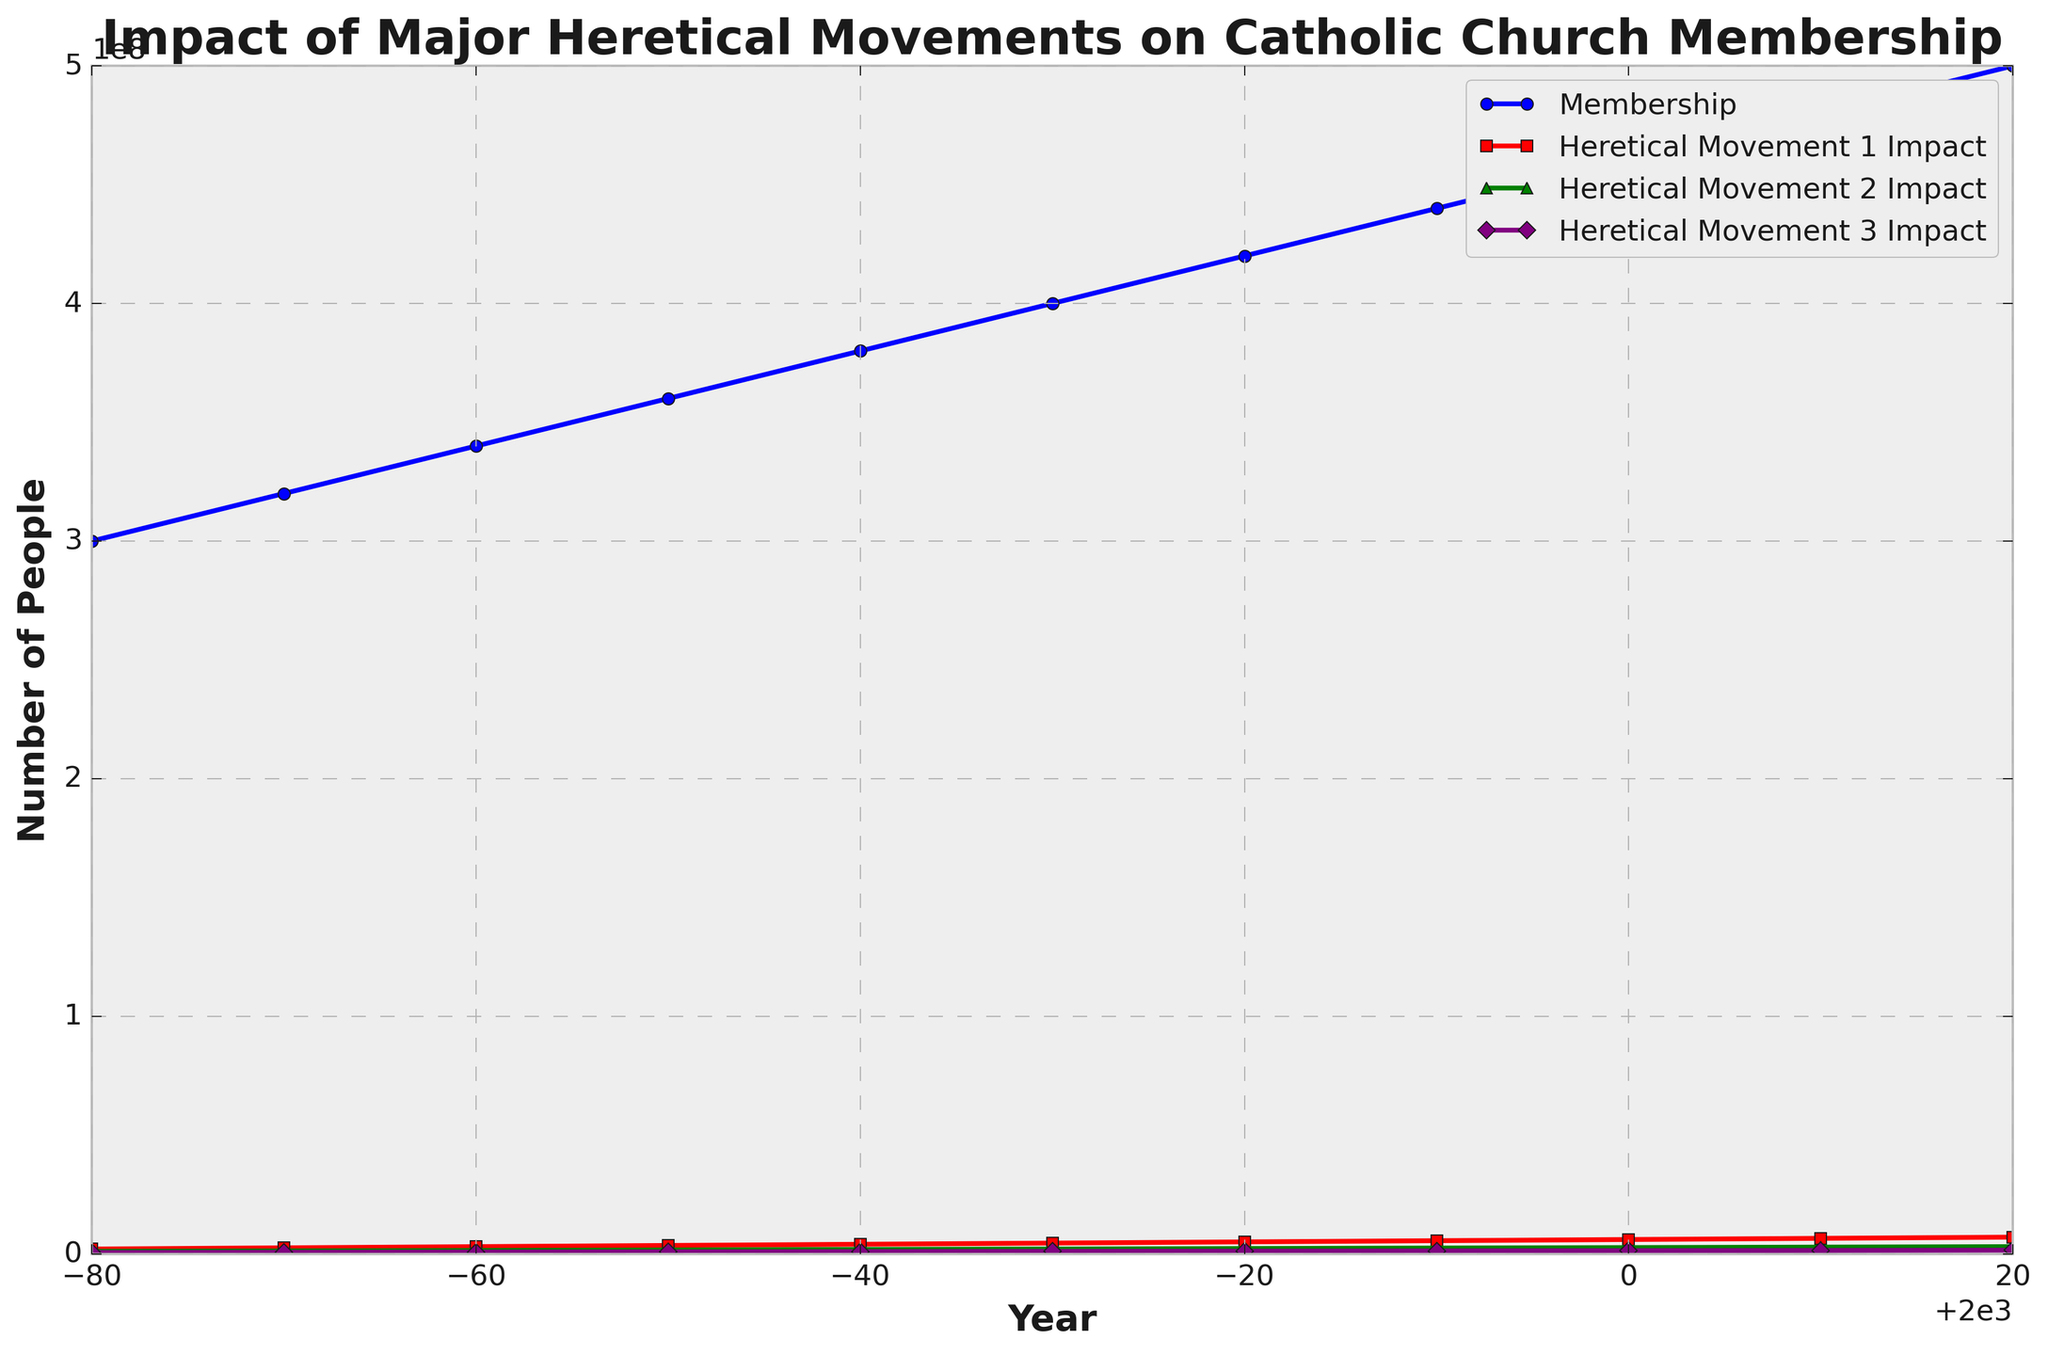What trend is visible in the Membership line from 1920 to 2020? The Membership line consistently rises from 1920 to 2020, indicating a steady increase in Catholic Church Membership over this century.
Answer: Steady increase Which heretical movement has the most significant impact in 2020 compared to the others? The Heretical Movement 1 Impact, represented by the red line, reaches 7,000,000 in 2020, which is higher than the impacts of the other heretical movements.
Answer: Heretical Movement 1 Compare the impact of Heretical Movement 2 and Heretical Movement 3 in 1960. In 1960, the Heretical Movement 2 Impact is 1,800,000 (green line), and the Heretical Movement 3 Impact is 900,000 (purple line), so Movement 2 has a higher impact.
Answer: Heretical Movement 2 Impact is higher What is the average membership between 1940 and 1980? The membership values between 1940 and 1980 are 340,000,000; 360,000,000; 380,000,000; 400,000,000; and 420,000,000. The average of these is (340,000,000 + 360,000,000 + 380,000,000 + 400,000,000 + 420,000,000) / 5 = 380,000,000.
Answer: 380,000,000 How does the impact of Heretical Movement 3 in 1970 compare to its impact in 1990? The impact of Heretical Movement 3 in 1970 is 1,000,000 (purple line), and in 1990, it is 1,200,000. The impact has increased by 200,000 over this period.
Answer: Increase by 200,000 Sum the impacts of all heretical movements in 1980. The impacts in 1980 are: Heretical Movement 1: 5,000,000; Heretical Movement 2: 2,200,000; Heretical Movement 3: 1,100,000. The sum is 5,000,000 + 2,200,000 + 1,100,000 = 8,300,000.
Answer: 8,300,000 In which year did the Membership line cross the 400,000,000 mark? The Membership line reached 400,000,000 in 1970.
Answer: 1970 What is the difference in Heretical Movement 1 Impact between 1930 and 1950? In 1930, the Heretical Movement 1 Impact is 2,500,000, and in 1950, it is 3,500,000. The difference is 3,500,000 - 2,500,000 = 1,000,000.
Answer: 1,000,000 